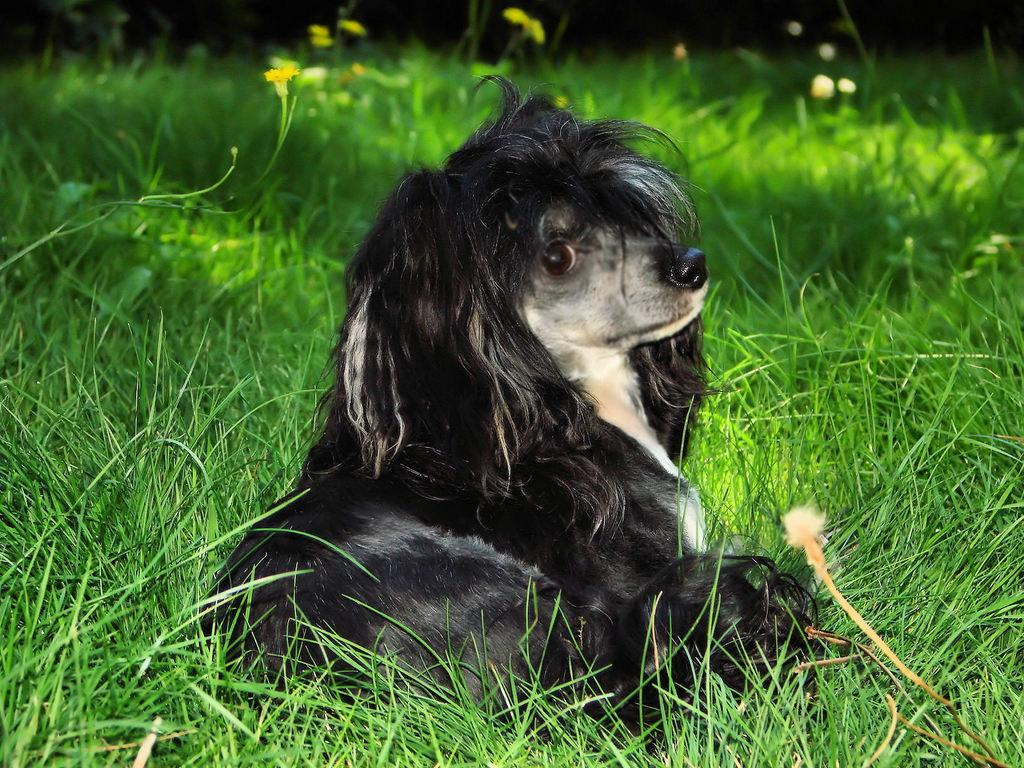What animal can be seen in the image? There is a dog in the image. What colors does the dog have? The dog is black and white in color. Where is the dog located in the image? The dog is on the ground. What type of surface is the dog standing on? There is grass on the ground. Are there any other plants visible in the image? Yes, yellow colored flowers are present on the ground. Can you tell me how many times the dog smiles in the image? Dogs do not smile like humans, so there is no smiling to count in the image. 